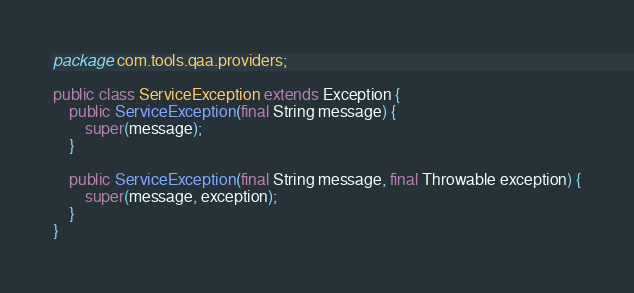<code> <loc_0><loc_0><loc_500><loc_500><_Java_>package com.tools.qaa.providers;

public class ServiceException extends Exception {
	public ServiceException(final String message) {
		super(message);
	}

	public ServiceException(final String message, final Throwable exception) {
		super(message, exception);
	}
}

</code> 